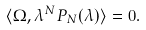<formula> <loc_0><loc_0><loc_500><loc_500>\langle \Omega , \lambda ^ { N } P _ { N } ( \lambda ) \rangle = 0 .</formula> 